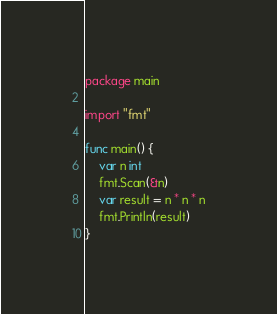Convert code to text. <code><loc_0><loc_0><loc_500><loc_500><_Go_>package main

import "fmt"

func main() {
	var n int
	fmt.Scan(&n)
	var result = n * n * n
	fmt.Println(result)
}
</code> 